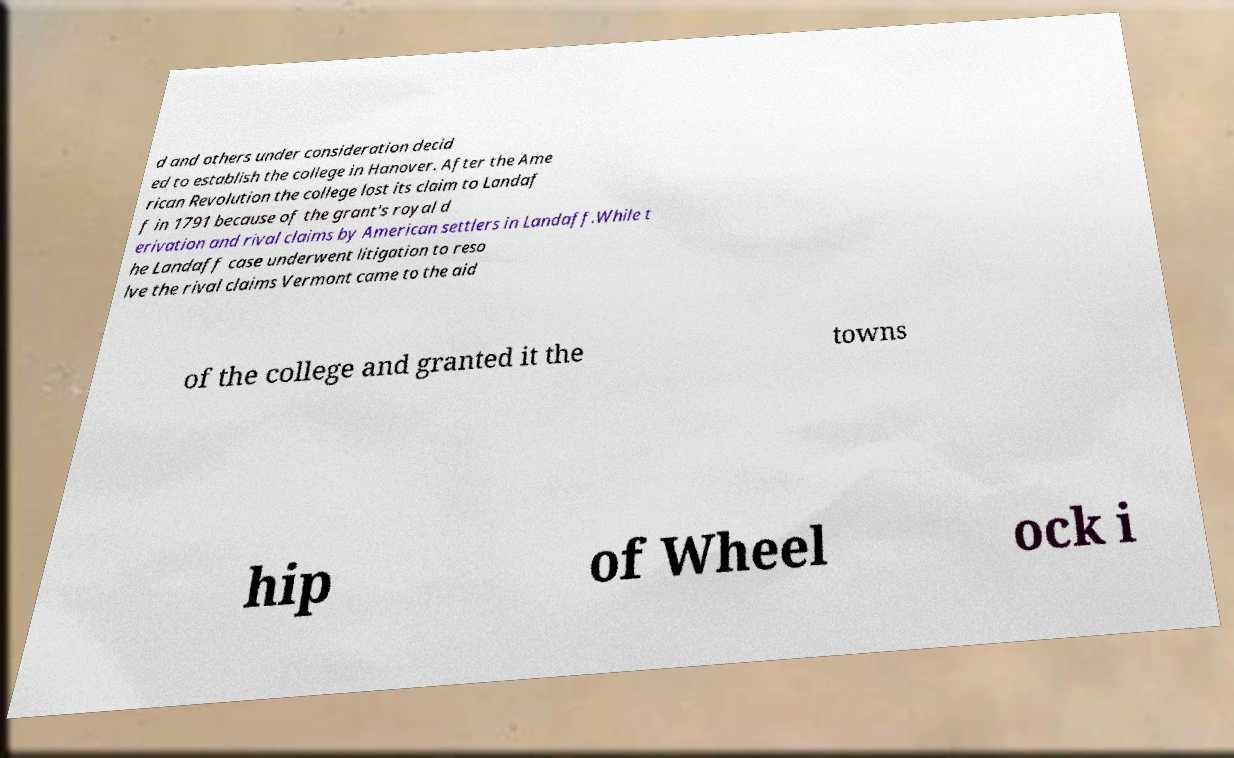Could you extract and type out the text from this image? d and others under consideration decid ed to establish the college in Hanover. After the Ame rican Revolution the college lost its claim to Landaf f in 1791 because of the grant's royal d erivation and rival claims by American settlers in Landaff.While t he Landaff case underwent litigation to reso lve the rival claims Vermont came to the aid of the college and granted it the towns hip of Wheel ock i 